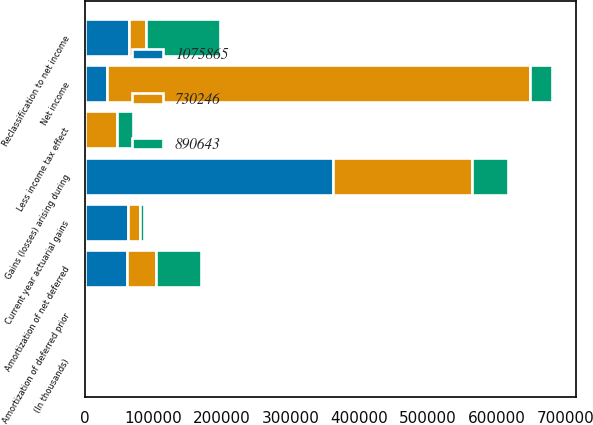Convert chart to OTSL. <chart><loc_0><loc_0><loc_500><loc_500><stacked_bar_chart><ecel><fcel>(In thousands)<fcel>Net income<fcel>Gains (losses) arising during<fcel>Less income tax effect<fcel>Current year actuarial gains<fcel>Amortization of net deferred<fcel>Amortization of deferred prior<fcel>Reclassification to net income<nl><fcel>730246<fcel>2017<fcel>614923<fcel>202428<fcel>45950<fcel>18130<fcel>41440<fcel>2646<fcel>24067<nl><fcel>890643<fcel>2016<fcel>32911<fcel>52028<fcel>24382<fcel>5384<fcel>65212<fcel>2584<fcel>107457<nl><fcel>1.07586e+06<fcel>2015<fcel>32911<fcel>361814<fcel>586<fcel>62556<fcel>61966<fcel>3038<fcel>64976<nl></chart> 